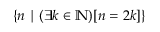<formula> <loc_0><loc_0><loc_500><loc_500>\{ n | ( \exists k \in \mathbb { N } ) [ n = 2 k ] \}</formula> 